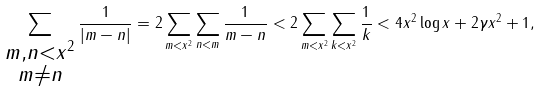<formula> <loc_0><loc_0><loc_500><loc_500>\sum _ { \substack { m , n < x ^ { 2 } \\ m \neq n } } \frac { 1 } { | m - n | } = 2 \sum _ { m < x ^ { 2 } } \sum _ { n < m } \frac { 1 } { m - n } & < 2 \sum _ { m < x ^ { 2 } } \sum _ { k < x ^ { 2 } } \frac { 1 } { k } < 4 x ^ { 2 } \log x + 2 \gamma x ^ { 2 } + 1 ,</formula> 